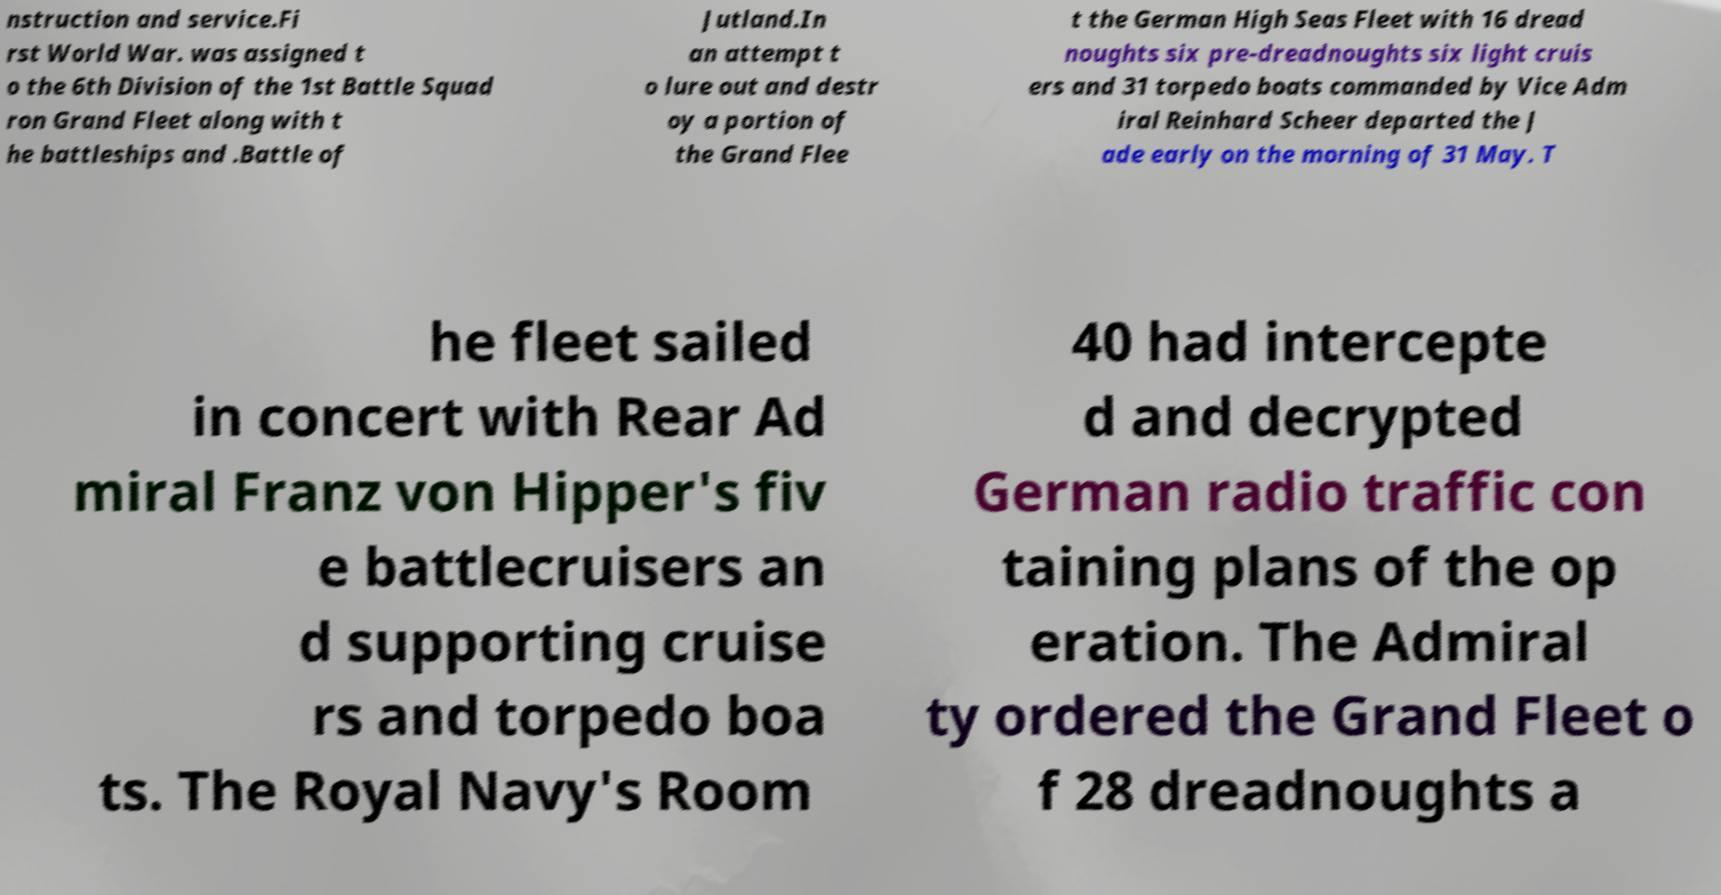I need the written content from this picture converted into text. Can you do that? nstruction and service.Fi rst World War. was assigned t o the 6th Division of the 1st Battle Squad ron Grand Fleet along with t he battleships and .Battle of Jutland.In an attempt t o lure out and destr oy a portion of the Grand Flee t the German High Seas Fleet with 16 dread noughts six pre-dreadnoughts six light cruis ers and 31 torpedo boats commanded by Vice Adm iral Reinhard Scheer departed the J ade early on the morning of 31 May. T he fleet sailed in concert with Rear Ad miral Franz von Hipper's fiv e battlecruisers an d supporting cruise rs and torpedo boa ts. The Royal Navy's Room 40 had intercepte d and decrypted German radio traffic con taining plans of the op eration. The Admiral ty ordered the Grand Fleet o f 28 dreadnoughts a 